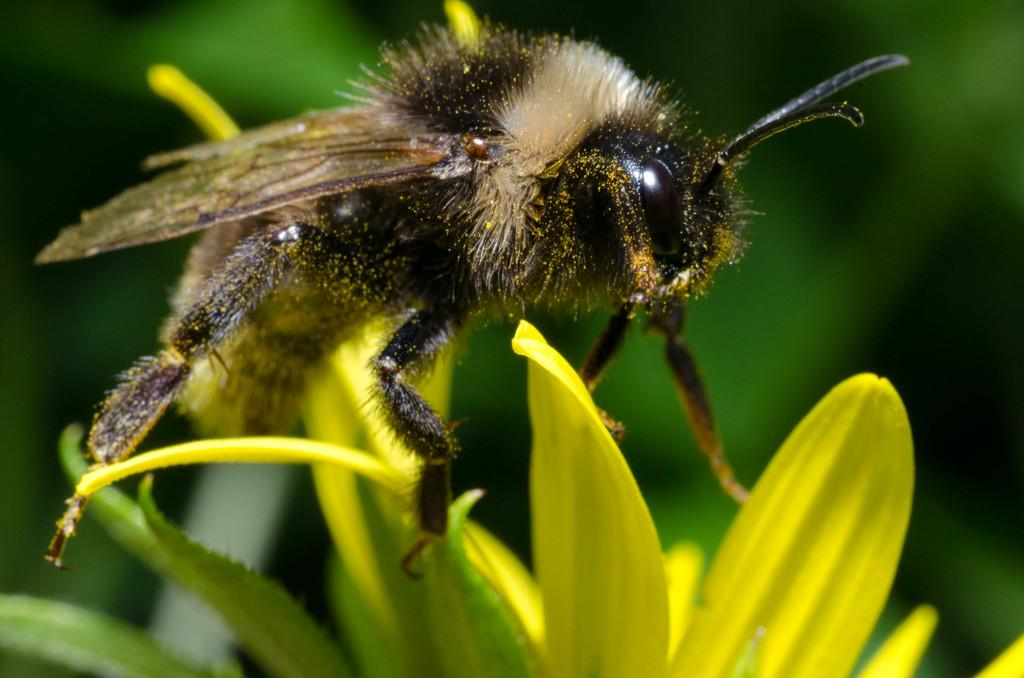What type of creature is present in the image? There is an insect in the image. Where is the insect located? The insect is on flower petals. Can you describe the background of the image? The background of the image is blurred. What type of toy can be seen on the calendar in the image? There is no toy or calendar present in the image. What time of day does the image depict, considering the lighting? The image does not provide enough information to determine the time of day based on lighting. 